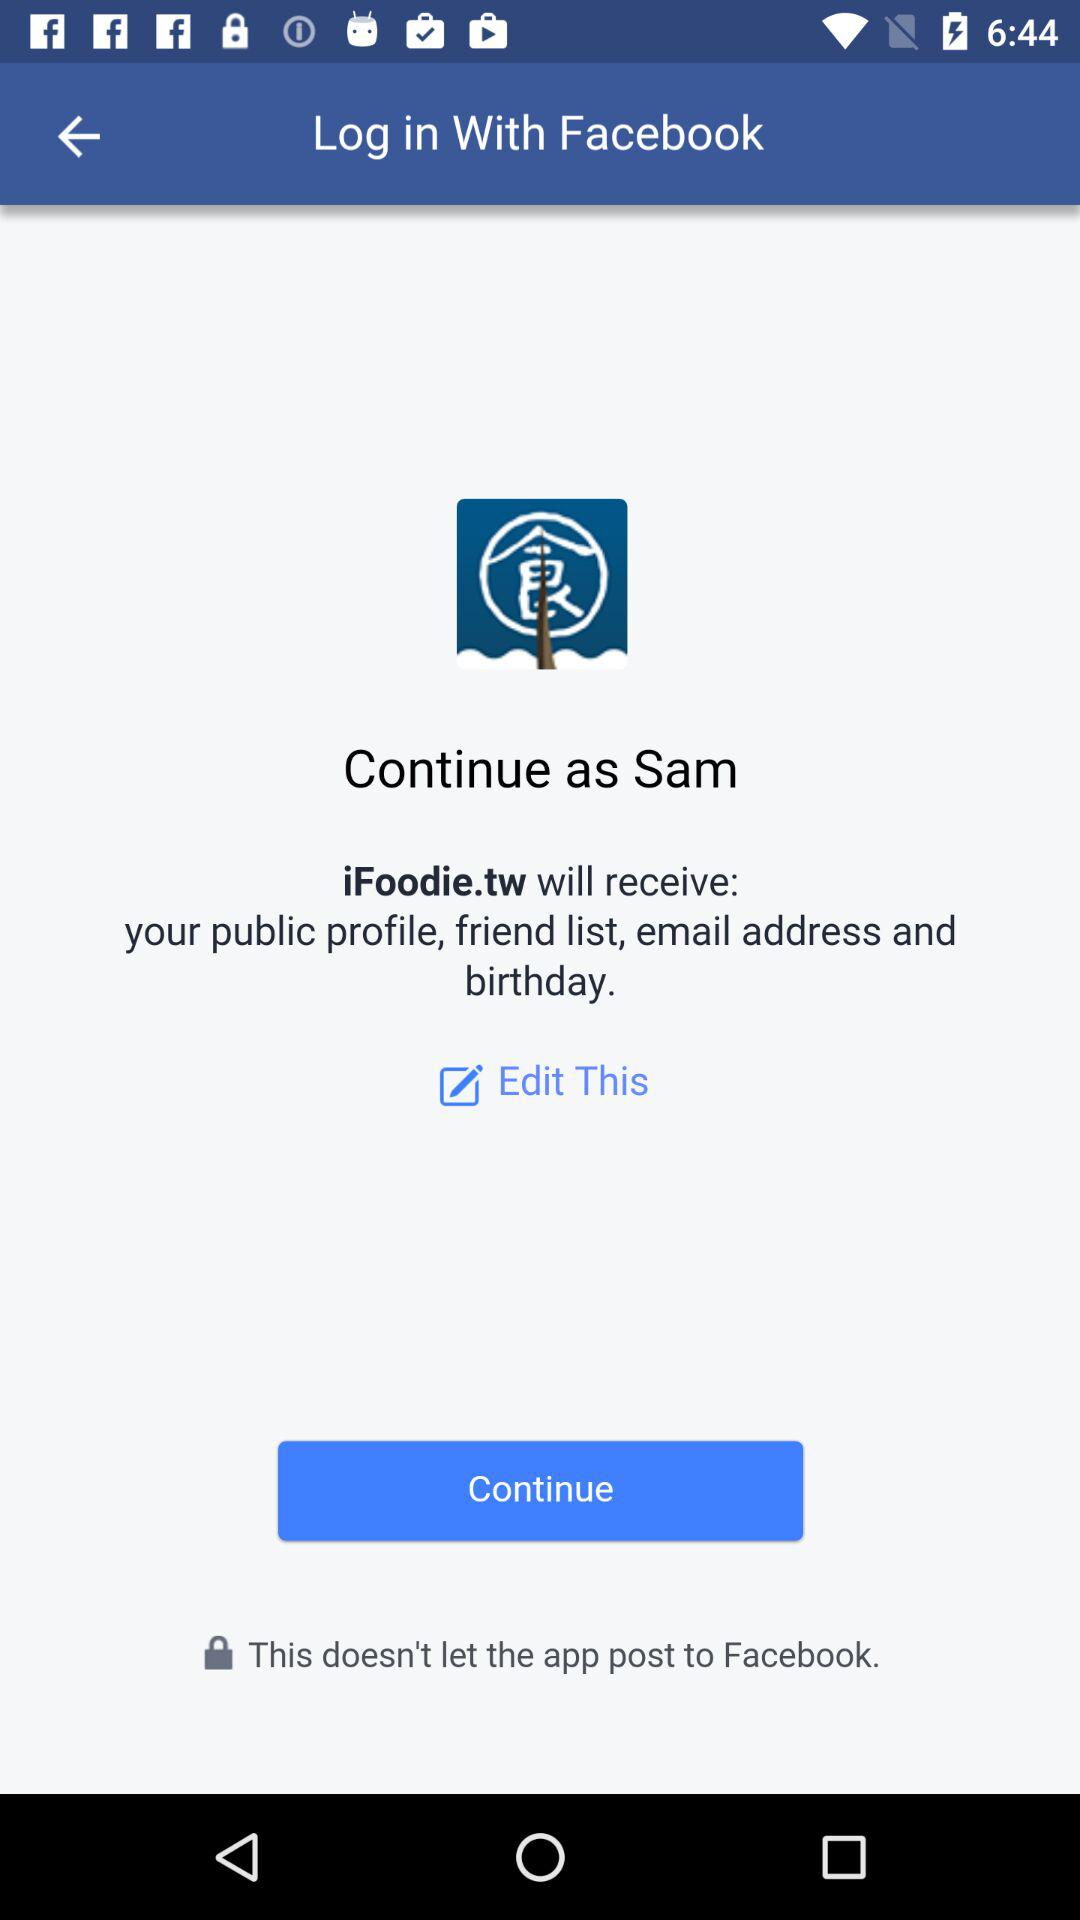What application can the user log in with? The user can log in with "Facebook". 